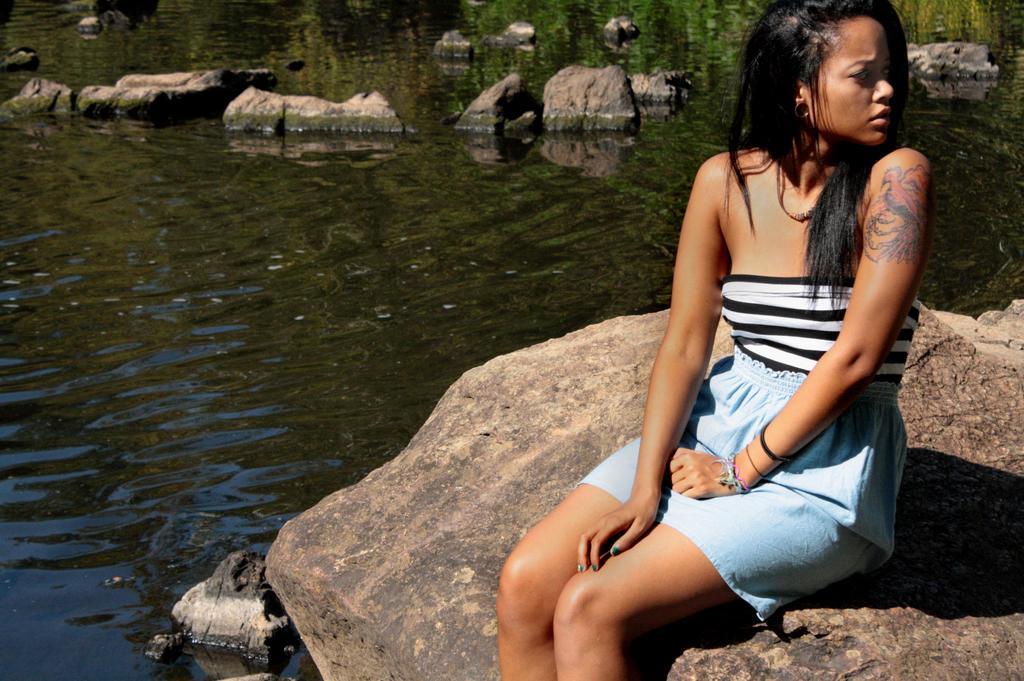How would you summarize this image in a sentence or two? In the picture we can see a woman sitting on the rock near the water and in her hand, we can see a tattoo and in the water we can see some rocks. 